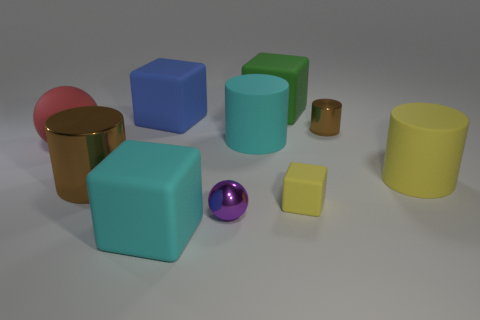What is the material of the large cyan thing behind the small metallic sphere?
Your answer should be compact. Rubber. There is a small yellow thing; is its shape the same as the big cyan object to the right of the purple metallic ball?
Your response must be concise. No. Is the number of small metallic cylinders to the right of the tiny brown thing the same as the number of metallic things left of the blue object?
Ensure brevity in your answer.  No. What number of other things are made of the same material as the tiny yellow object?
Keep it short and to the point. 6. How many rubber things are small spheres or large brown things?
Ensure brevity in your answer.  0. Does the yellow thing in front of the big brown metallic thing have the same shape as the big red object?
Provide a succinct answer. No. Are there more small brown things that are in front of the tiny matte cube than rubber cylinders?
Give a very brief answer. No. How many large matte objects are on the right side of the large blue block and in front of the blue object?
Keep it short and to the point. 3. The small metallic object in front of the tiny shiny object behind the large yellow thing is what color?
Your answer should be compact. Purple. What number of tiny rubber objects have the same color as the tiny matte cube?
Provide a succinct answer. 0. 